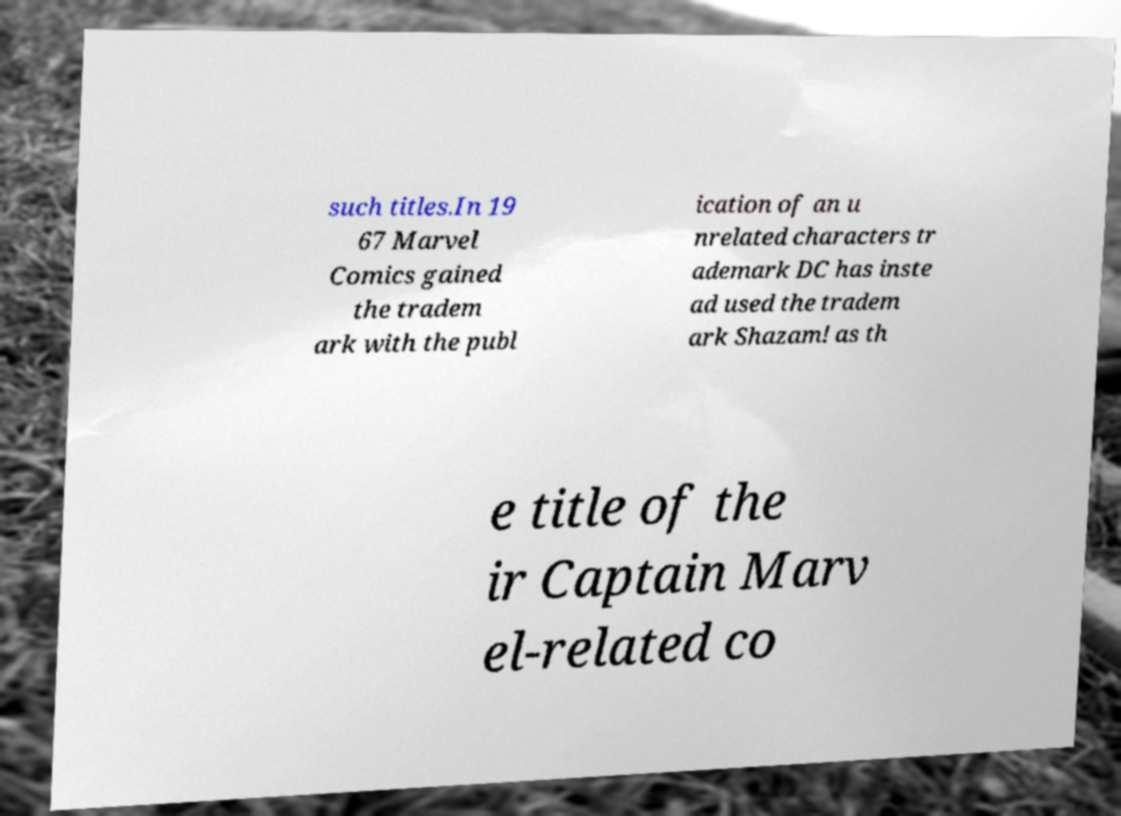There's text embedded in this image that I need extracted. Can you transcribe it verbatim? such titles.In 19 67 Marvel Comics gained the tradem ark with the publ ication of an u nrelated characters tr ademark DC has inste ad used the tradem ark Shazam! as th e title of the ir Captain Marv el-related co 